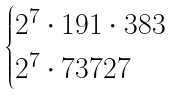<formula> <loc_0><loc_0><loc_500><loc_500>\begin{cases} 2 ^ { 7 } \cdot 1 9 1 \cdot 3 8 3 \\ 2 ^ { 7 } \cdot 7 3 7 2 7 \end{cases}</formula> 